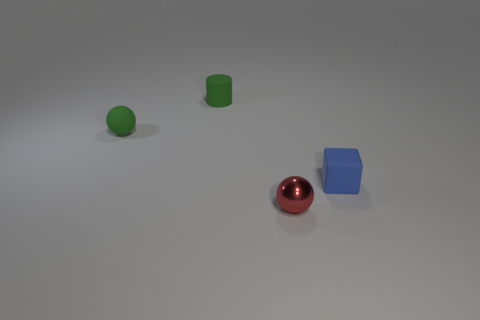Add 1 big cylinders. How many objects exist? 5 Subtract all cubes. How many objects are left? 3 Add 2 blue shiny cubes. How many blue shiny cubes exist? 2 Subtract 0 gray blocks. How many objects are left? 4 Subtract all red things. Subtract all small shiny spheres. How many objects are left? 2 Add 2 tiny shiny balls. How many tiny shiny balls are left? 3 